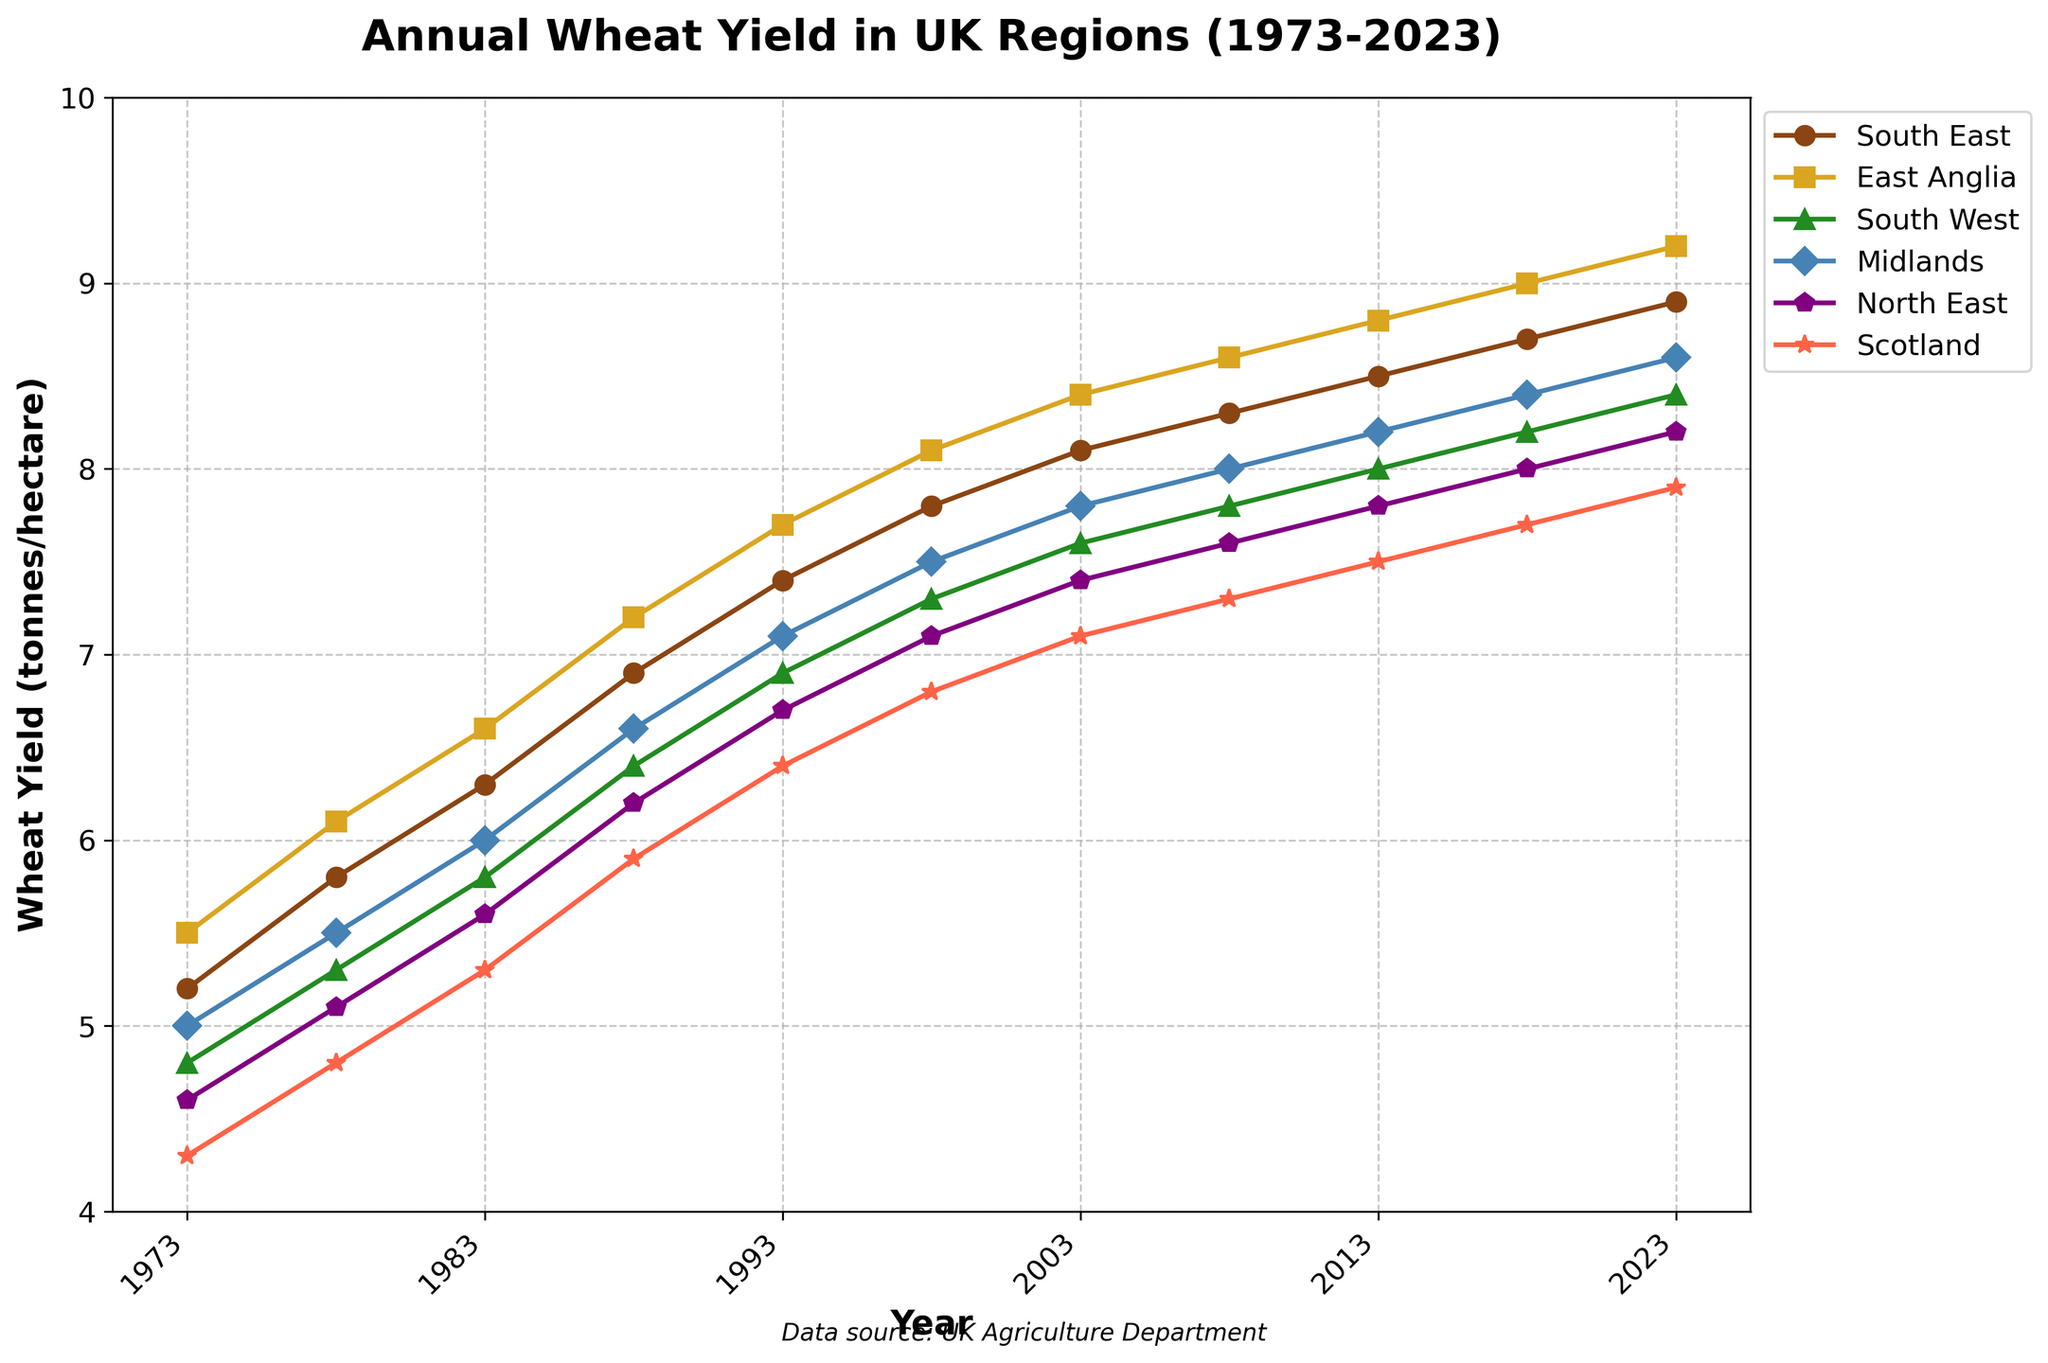What's the trend of the wheat yield in East Anglia over the past 50 years? The wheat yield in East Anglia has shown a steady increase from 5.5 tonnes/hectare in 1973 to 9.2 tonnes/hectare in 2023, indicating continuous improvement in yield over time.
Answer: Increasing Which region had the lowest wheat yield in 2023? By looking at the year 2023 on the figure, we see that Scotland had the lowest yield at 7.9 tonnes/hectare.
Answer: Scotland In which year did the Midlands surpass a yield of 8 tonnes/hectare? The plot shows that Midlands surpassed a yield of 8 tonnes/hectare in the year 2008 with a yield of 8.0 tonnes/hectare.
Answer: 2008 Which two regions showed the most similar yield trends over the years? By examining the curves, the South East and the South West lines are quite close to each other, indicating similar yield trends over the years.
Answer: South East and South West How much did the wheat yield increase in the South West from 1973 to 2023? The yield in the South West increased from 4.8 tonnes/hectare in 1973 to 8.4 tonnes/hectare in 2023. The increase is 8.4 - 4.8 = 3.6 tonnes/hectare.
Answer: 3.6 tonnes/hectare Which region's wheat yield showed the highest overall increase since 1973? Calculate the increase for each region from 1973 to 2023: South East (3.7), East Anglia (3.7), South West (3.6), Midlands (3.6), North East (3.6), Scotland (3.6). Both South East and East Anglia had the highest increase of 3.7 tonnes/hectare.
Answer: South East and East Anglia Between 1998 and 2003, which region had the smallest increase in wheat yield? Subtract the 1998 yields from 2003 yields for each region: South East (0.3), East Anglia (0.3), South West (0.3), Midlands (0.3), North East (0.3), Scotland (0.3). All regions had the same increase of 0.3 tonnes/hectare.
Answer: All regions What's the difference in wheat yield between the North East and Scotland in 2023? Look at the yields in 2023; the North East has 8.2 tonnes/hectare, and Scotland has 7.9 tonnes/hectare. The difference is 8.2 - 7.9 = 0.3 tonnes/hectare.
Answer: 0.3 tonnes/hectare 